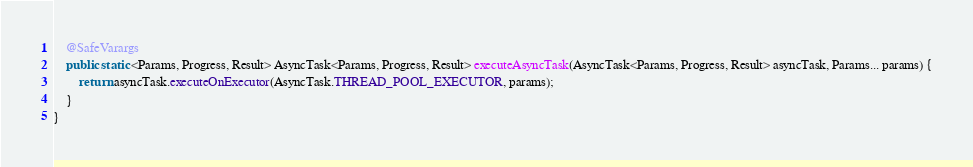<code> <loc_0><loc_0><loc_500><loc_500><_Java_>    @SafeVarargs
    public static <Params, Progress, Result> AsyncTask<Params, Progress, Result> executeAsyncTask(AsyncTask<Params, Progress, Result> asyncTask, Params... params) {
        return asyncTask.executeOnExecutor(AsyncTask.THREAD_POOL_EXECUTOR, params);
    }
}
</code> 